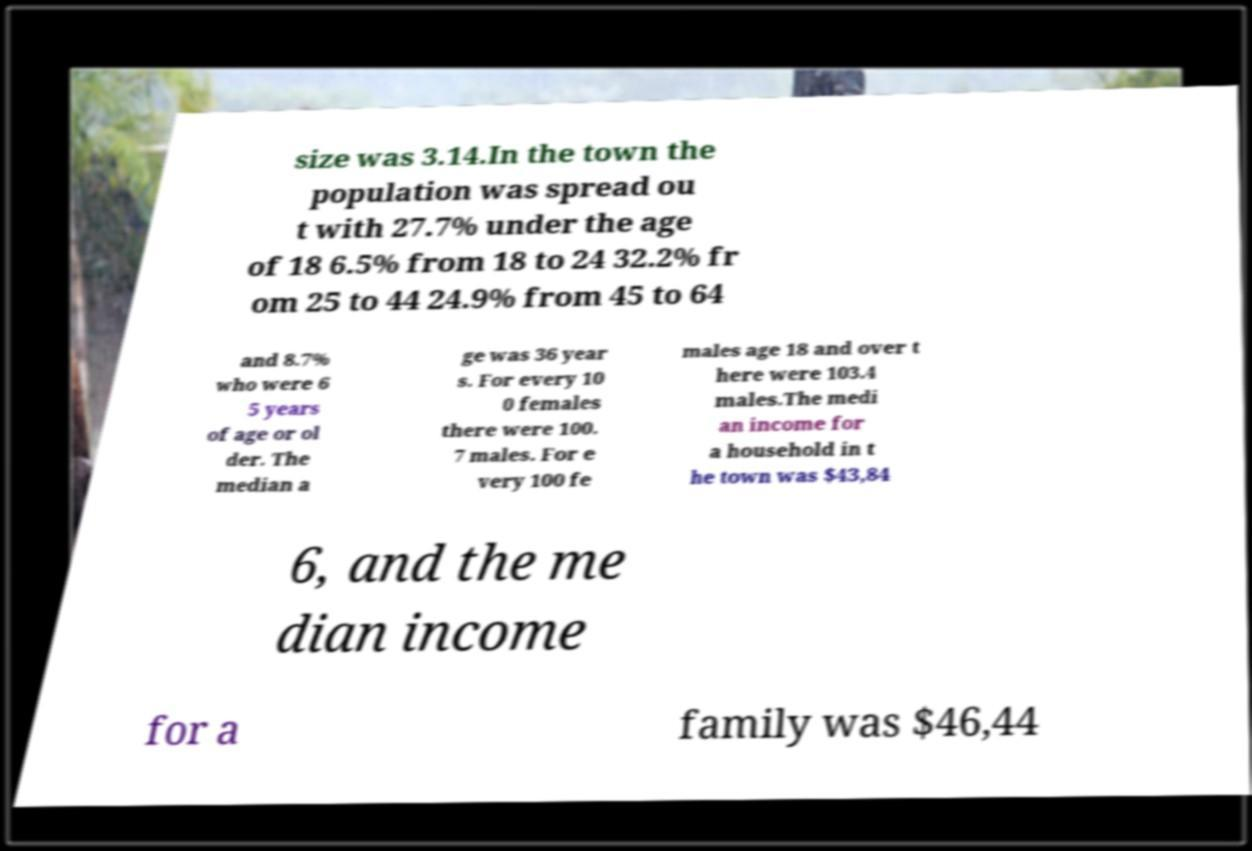Can you read and provide the text displayed in the image?This photo seems to have some interesting text. Can you extract and type it out for me? size was 3.14.In the town the population was spread ou t with 27.7% under the age of 18 6.5% from 18 to 24 32.2% fr om 25 to 44 24.9% from 45 to 64 and 8.7% who were 6 5 years of age or ol der. The median a ge was 36 year s. For every 10 0 females there were 100. 7 males. For e very 100 fe males age 18 and over t here were 103.4 males.The medi an income for a household in t he town was $43,84 6, and the me dian income for a family was $46,44 